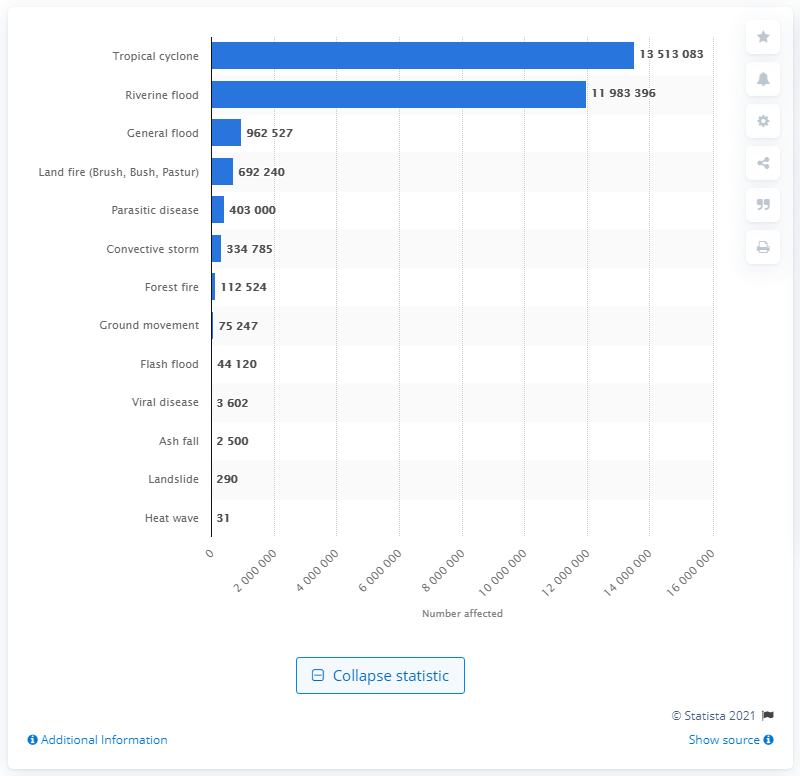Give some essential details in this illustration. During the period from 1900 to 2016, a total of 135,130,836 people were affected by tropical cyclones in the United States. 